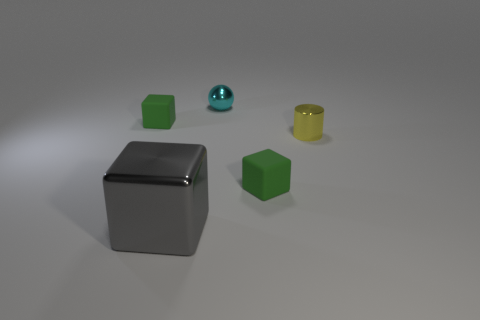Subtract all small cubes. How many cubes are left? 1 Add 1 gray cubes. How many objects exist? 6 Subtract all green balls. How many green cubes are left? 2 Subtract all gray blocks. How many blocks are left? 2 Add 4 metal balls. How many metal balls are left? 5 Add 3 large gray cubes. How many large gray cubes exist? 4 Subtract 2 green blocks. How many objects are left? 3 Subtract all cylinders. How many objects are left? 4 Subtract all cyan cubes. Subtract all purple cylinders. How many cubes are left? 3 Subtract all tiny cyan shiny things. Subtract all tiny green objects. How many objects are left? 2 